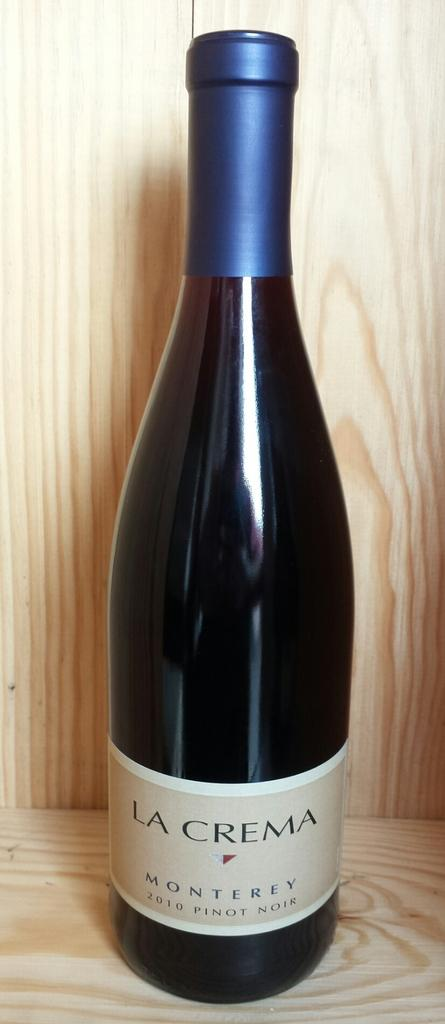Provide a one-sentence caption for the provided image. A bottle of La Crema Monterey 2010 Pinot Noir sits on a wood display. 